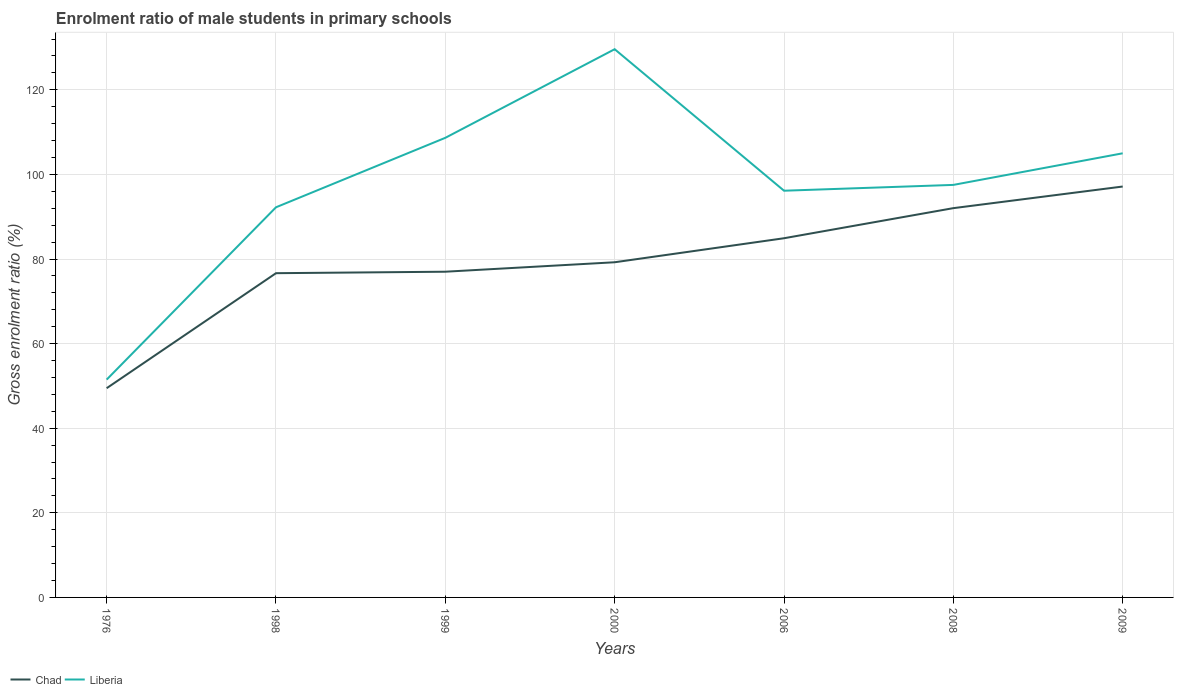How many different coloured lines are there?
Provide a short and direct response. 2. Is the number of lines equal to the number of legend labels?
Your response must be concise. Yes. Across all years, what is the maximum enrolment ratio of male students in primary schools in Chad?
Make the answer very short. 49.46. In which year was the enrolment ratio of male students in primary schools in Liberia maximum?
Give a very brief answer. 1976. What is the total enrolment ratio of male students in primary schools in Chad in the graph?
Your response must be concise. -29.77. What is the difference between the highest and the second highest enrolment ratio of male students in primary schools in Chad?
Your answer should be compact. 47.68. What is the difference between the highest and the lowest enrolment ratio of male students in primary schools in Liberia?
Make the answer very short. 4. How many lines are there?
Give a very brief answer. 2. How many years are there in the graph?
Keep it short and to the point. 7. Are the values on the major ticks of Y-axis written in scientific E-notation?
Your response must be concise. No. Does the graph contain any zero values?
Your answer should be compact. No. Does the graph contain grids?
Your answer should be compact. Yes. How are the legend labels stacked?
Provide a short and direct response. Horizontal. What is the title of the graph?
Provide a succinct answer. Enrolment ratio of male students in primary schools. What is the label or title of the X-axis?
Your response must be concise. Years. What is the label or title of the Y-axis?
Your response must be concise. Gross enrolment ratio (%). What is the Gross enrolment ratio (%) of Chad in 1976?
Make the answer very short. 49.46. What is the Gross enrolment ratio (%) in Liberia in 1976?
Your answer should be very brief. 51.49. What is the Gross enrolment ratio (%) of Chad in 1998?
Offer a very short reply. 76.65. What is the Gross enrolment ratio (%) in Liberia in 1998?
Make the answer very short. 92.23. What is the Gross enrolment ratio (%) in Chad in 1999?
Provide a succinct answer. 77. What is the Gross enrolment ratio (%) of Liberia in 1999?
Your answer should be compact. 108.65. What is the Gross enrolment ratio (%) in Chad in 2000?
Offer a very short reply. 79.23. What is the Gross enrolment ratio (%) in Liberia in 2000?
Give a very brief answer. 129.6. What is the Gross enrolment ratio (%) of Chad in 2006?
Ensure brevity in your answer.  84.91. What is the Gross enrolment ratio (%) of Liberia in 2006?
Your answer should be very brief. 96.14. What is the Gross enrolment ratio (%) in Chad in 2008?
Offer a very short reply. 92.02. What is the Gross enrolment ratio (%) of Liberia in 2008?
Keep it short and to the point. 97.52. What is the Gross enrolment ratio (%) of Chad in 2009?
Offer a very short reply. 97.14. What is the Gross enrolment ratio (%) in Liberia in 2009?
Provide a short and direct response. 104.99. Across all years, what is the maximum Gross enrolment ratio (%) in Chad?
Give a very brief answer. 97.14. Across all years, what is the maximum Gross enrolment ratio (%) of Liberia?
Your answer should be compact. 129.6. Across all years, what is the minimum Gross enrolment ratio (%) of Chad?
Make the answer very short. 49.46. Across all years, what is the minimum Gross enrolment ratio (%) in Liberia?
Give a very brief answer. 51.49. What is the total Gross enrolment ratio (%) in Chad in the graph?
Keep it short and to the point. 556.4. What is the total Gross enrolment ratio (%) in Liberia in the graph?
Offer a terse response. 680.62. What is the difference between the Gross enrolment ratio (%) of Chad in 1976 and that in 1998?
Keep it short and to the point. -27.19. What is the difference between the Gross enrolment ratio (%) of Liberia in 1976 and that in 1998?
Your answer should be very brief. -40.74. What is the difference between the Gross enrolment ratio (%) of Chad in 1976 and that in 1999?
Your answer should be very brief. -27.54. What is the difference between the Gross enrolment ratio (%) of Liberia in 1976 and that in 1999?
Your response must be concise. -57.16. What is the difference between the Gross enrolment ratio (%) in Chad in 1976 and that in 2000?
Your answer should be very brief. -29.77. What is the difference between the Gross enrolment ratio (%) in Liberia in 1976 and that in 2000?
Your answer should be very brief. -78.11. What is the difference between the Gross enrolment ratio (%) of Chad in 1976 and that in 2006?
Keep it short and to the point. -35.45. What is the difference between the Gross enrolment ratio (%) of Liberia in 1976 and that in 2006?
Provide a short and direct response. -44.65. What is the difference between the Gross enrolment ratio (%) of Chad in 1976 and that in 2008?
Ensure brevity in your answer.  -42.56. What is the difference between the Gross enrolment ratio (%) of Liberia in 1976 and that in 2008?
Your answer should be very brief. -46.03. What is the difference between the Gross enrolment ratio (%) of Chad in 1976 and that in 2009?
Make the answer very short. -47.68. What is the difference between the Gross enrolment ratio (%) in Liberia in 1976 and that in 2009?
Give a very brief answer. -53.5. What is the difference between the Gross enrolment ratio (%) in Chad in 1998 and that in 1999?
Your answer should be very brief. -0.35. What is the difference between the Gross enrolment ratio (%) in Liberia in 1998 and that in 1999?
Your answer should be very brief. -16.42. What is the difference between the Gross enrolment ratio (%) of Chad in 1998 and that in 2000?
Give a very brief answer. -2.58. What is the difference between the Gross enrolment ratio (%) of Liberia in 1998 and that in 2000?
Your response must be concise. -37.37. What is the difference between the Gross enrolment ratio (%) of Chad in 1998 and that in 2006?
Keep it short and to the point. -8.26. What is the difference between the Gross enrolment ratio (%) of Liberia in 1998 and that in 2006?
Keep it short and to the point. -3.92. What is the difference between the Gross enrolment ratio (%) in Chad in 1998 and that in 2008?
Your answer should be compact. -15.38. What is the difference between the Gross enrolment ratio (%) in Liberia in 1998 and that in 2008?
Ensure brevity in your answer.  -5.29. What is the difference between the Gross enrolment ratio (%) in Chad in 1998 and that in 2009?
Your answer should be very brief. -20.49. What is the difference between the Gross enrolment ratio (%) in Liberia in 1998 and that in 2009?
Give a very brief answer. -12.76. What is the difference between the Gross enrolment ratio (%) in Chad in 1999 and that in 2000?
Provide a short and direct response. -2.23. What is the difference between the Gross enrolment ratio (%) of Liberia in 1999 and that in 2000?
Your answer should be very brief. -20.95. What is the difference between the Gross enrolment ratio (%) of Chad in 1999 and that in 2006?
Offer a very short reply. -7.91. What is the difference between the Gross enrolment ratio (%) of Liberia in 1999 and that in 2006?
Your answer should be compact. 12.51. What is the difference between the Gross enrolment ratio (%) in Chad in 1999 and that in 2008?
Provide a succinct answer. -15.03. What is the difference between the Gross enrolment ratio (%) in Liberia in 1999 and that in 2008?
Make the answer very short. 11.13. What is the difference between the Gross enrolment ratio (%) of Chad in 1999 and that in 2009?
Your answer should be compact. -20.14. What is the difference between the Gross enrolment ratio (%) in Liberia in 1999 and that in 2009?
Offer a terse response. 3.66. What is the difference between the Gross enrolment ratio (%) of Chad in 2000 and that in 2006?
Make the answer very short. -5.68. What is the difference between the Gross enrolment ratio (%) in Liberia in 2000 and that in 2006?
Ensure brevity in your answer.  33.45. What is the difference between the Gross enrolment ratio (%) of Chad in 2000 and that in 2008?
Your answer should be compact. -12.79. What is the difference between the Gross enrolment ratio (%) in Liberia in 2000 and that in 2008?
Offer a terse response. 32.08. What is the difference between the Gross enrolment ratio (%) in Chad in 2000 and that in 2009?
Provide a succinct answer. -17.9. What is the difference between the Gross enrolment ratio (%) in Liberia in 2000 and that in 2009?
Provide a short and direct response. 24.61. What is the difference between the Gross enrolment ratio (%) of Chad in 2006 and that in 2008?
Offer a very short reply. -7.11. What is the difference between the Gross enrolment ratio (%) of Liberia in 2006 and that in 2008?
Offer a very short reply. -1.37. What is the difference between the Gross enrolment ratio (%) in Chad in 2006 and that in 2009?
Provide a short and direct response. -12.23. What is the difference between the Gross enrolment ratio (%) of Liberia in 2006 and that in 2009?
Offer a terse response. -8.84. What is the difference between the Gross enrolment ratio (%) in Chad in 2008 and that in 2009?
Your answer should be very brief. -5.11. What is the difference between the Gross enrolment ratio (%) in Liberia in 2008 and that in 2009?
Ensure brevity in your answer.  -7.47. What is the difference between the Gross enrolment ratio (%) in Chad in 1976 and the Gross enrolment ratio (%) in Liberia in 1998?
Offer a terse response. -42.77. What is the difference between the Gross enrolment ratio (%) of Chad in 1976 and the Gross enrolment ratio (%) of Liberia in 1999?
Ensure brevity in your answer.  -59.19. What is the difference between the Gross enrolment ratio (%) of Chad in 1976 and the Gross enrolment ratio (%) of Liberia in 2000?
Offer a terse response. -80.14. What is the difference between the Gross enrolment ratio (%) of Chad in 1976 and the Gross enrolment ratio (%) of Liberia in 2006?
Your response must be concise. -46.68. What is the difference between the Gross enrolment ratio (%) in Chad in 1976 and the Gross enrolment ratio (%) in Liberia in 2008?
Your answer should be compact. -48.06. What is the difference between the Gross enrolment ratio (%) of Chad in 1976 and the Gross enrolment ratio (%) of Liberia in 2009?
Keep it short and to the point. -55.53. What is the difference between the Gross enrolment ratio (%) in Chad in 1998 and the Gross enrolment ratio (%) in Liberia in 1999?
Give a very brief answer. -32. What is the difference between the Gross enrolment ratio (%) of Chad in 1998 and the Gross enrolment ratio (%) of Liberia in 2000?
Keep it short and to the point. -52.95. What is the difference between the Gross enrolment ratio (%) in Chad in 1998 and the Gross enrolment ratio (%) in Liberia in 2006?
Offer a terse response. -19.5. What is the difference between the Gross enrolment ratio (%) in Chad in 1998 and the Gross enrolment ratio (%) in Liberia in 2008?
Provide a short and direct response. -20.87. What is the difference between the Gross enrolment ratio (%) in Chad in 1998 and the Gross enrolment ratio (%) in Liberia in 2009?
Give a very brief answer. -28.34. What is the difference between the Gross enrolment ratio (%) in Chad in 1999 and the Gross enrolment ratio (%) in Liberia in 2000?
Offer a very short reply. -52.6. What is the difference between the Gross enrolment ratio (%) of Chad in 1999 and the Gross enrolment ratio (%) of Liberia in 2006?
Offer a very short reply. -19.15. What is the difference between the Gross enrolment ratio (%) in Chad in 1999 and the Gross enrolment ratio (%) in Liberia in 2008?
Give a very brief answer. -20.52. What is the difference between the Gross enrolment ratio (%) in Chad in 1999 and the Gross enrolment ratio (%) in Liberia in 2009?
Offer a very short reply. -27.99. What is the difference between the Gross enrolment ratio (%) of Chad in 2000 and the Gross enrolment ratio (%) of Liberia in 2006?
Ensure brevity in your answer.  -16.91. What is the difference between the Gross enrolment ratio (%) in Chad in 2000 and the Gross enrolment ratio (%) in Liberia in 2008?
Provide a succinct answer. -18.29. What is the difference between the Gross enrolment ratio (%) in Chad in 2000 and the Gross enrolment ratio (%) in Liberia in 2009?
Offer a terse response. -25.76. What is the difference between the Gross enrolment ratio (%) of Chad in 2006 and the Gross enrolment ratio (%) of Liberia in 2008?
Provide a short and direct response. -12.61. What is the difference between the Gross enrolment ratio (%) in Chad in 2006 and the Gross enrolment ratio (%) in Liberia in 2009?
Your answer should be compact. -20.08. What is the difference between the Gross enrolment ratio (%) in Chad in 2008 and the Gross enrolment ratio (%) in Liberia in 2009?
Offer a very short reply. -12.97. What is the average Gross enrolment ratio (%) in Chad per year?
Keep it short and to the point. 79.49. What is the average Gross enrolment ratio (%) of Liberia per year?
Give a very brief answer. 97.23. In the year 1976, what is the difference between the Gross enrolment ratio (%) of Chad and Gross enrolment ratio (%) of Liberia?
Your response must be concise. -2.03. In the year 1998, what is the difference between the Gross enrolment ratio (%) of Chad and Gross enrolment ratio (%) of Liberia?
Your answer should be very brief. -15.58. In the year 1999, what is the difference between the Gross enrolment ratio (%) of Chad and Gross enrolment ratio (%) of Liberia?
Offer a terse response. -31.65. In the year 2000, what is the difference between the Gross enrolment ratio (%) of Chad and Gross enrolment ratio (%) of Liberia?
Offer a very short reply. -50.37. In the year 2006, what is the difference between the Gross enrolment ratio (%) in Chad and Gross enrolment ratio (%) in Liberia?
Provide a short and direct response. -11.24. In the year 2008, what is the difference between the Gross enrolment ratio (%) in Chad and Gross enrolment ratio (%) in Liberia?
Offer a very short reply. -5.49. In the year 2009, what is the difference between the Gross enrolment ratio (%) of Chad and Gross enrolment ratio (%) of Liberia?
Your response must be concise. -7.85. What is the ratio of the Gross enrolment ratio (%) of Chad in 1976 to that in 1998?
Your answer should be compact. 0.65. What is the ratio of the Gross enrolment ratio (%) in Liberia in 1976 to that in 1998?
Offer a terse response. 0.56. What is the ratio of the Gross enrolment ratio (%) of Chad in 1976 to that in 1999?
Offer a very short reply. 0.64. What is the ratio of the Gross enrolment ratio (%) in Liberia in 1976 to that in 1999?
Provide a succinct answer. 0.47. What is the ratio of the Gross enrolment ratio (%) in Chad in 1976 to that in 2000?
Give a very brief answer. 0.62. What is the ratio of the Gross enrolment ratio (%) in Liberia in 1976 to that in 2000?
Give a very brief answer. 0.4. What is the ratio of the Gross enrolment ratio (%) of Chad in 1976 to that in 2006?
Make the answer very short. 0.58. What is the ratio of the Gross enrolment ratio (%) in Liberia in 1976 to that in 2006?
Keep it short and to the point. 0.54. What is the ratio of the Gross enrolment ratio (%) in Chad in 1976 to that in 2008?
Offer a terse response. 0.54. What is the ratio of the Gross enrolment ratio (%) in Liberia in 1976 to that in 2008?
Your answer should be very brief. 0.53. What is the ratio of the Gross enrolment ratio (%) in Chad in 1976 to that in 2009?
Ensure brevity in your answer.  0.51. What is the ratio of the Gross enrolment ratio (%) in Liberia in 1976 to that in 2009?
Your answer should be compact. 0.49. What is the ratio of the Gross enrolment ratio (%) in Chad in 1998 to that in 1999?
Give a very brief answer. 1. What is the ratio of the Gross enrolment ratio (%) of Liberia in 1998 to that in 1999?
Ensure brevity in your answer.  0.85. What is the ratio of the Gross enrolment ratio (%) in Chad in 1998 to that in 2000?
Offer a very short reply. 0.97. What is the ratio of the Gross enrolment ratio (%) of Liberia in 1998 to that in 2000?
Offer a very short reply. 0.71. What is the ratio of the Gross enrolment ratio (%) in Chad in 1998 to that in 2006?
Offer a terse response. 0.9. What is the ratio of the Gross enrolment ratio (%) of Liberia in 1998 to that in 2006?
Make the answer very short. 0.96. What is the ratio of the Gross enrolment ratio (%) in Chad in 1998 to that in 2008?
Keep it short and to the point. 0.83. What is the ratio of the Gross enrolment ratio (%) in Liberia in 1998 to that in 2008?
Offer a very short reply. 0.95. What is the ratio of the Gross enrolment ratio (%) in Chad in 1998 to that in 2009?
Your answer should be compact. 0.79. What is the ratio of the Gross enrolment ratio (%) in Liberia in 1998 to that in 2009?
Offer a terse response. 0.88. What is the ratio of the Gross enrolment ratio (%) of Chad in 1999 to that in 2000?
Make the answer very short. 0.97. What is the ratio of the Gross enrolment ratio (%) of Liberia in 1999 to that in 2000?
Keep it short and to the point. 0.84. What is the ratio of the Gross enrolment ratio (%) of Chad in 1999 to that in 2006?
Make the answer very short. 0.91. What is the ratio of the Gross enrolment ratio (%) in Liberia in 1999 to that in 2006?
Provide a short and direct response. 1.13. What is the ratio of the Gross enrolment ratio (%) of Chad in 1999 to that in 2008?
Ensure brevity in your answer.  0.84. What is the ratio of the Gross enrolment ratio (%) of Liberia in 1999 to that in 2008?
Provide a succinct answer. 1.11. What is the ratio of the Gross enrolment ratio (%) of Chad in 1999 to that in 2009?
Your response must be concise. 0.79. What is the ratio of the Gross enrolment ratio (%) in Liberia in 1999 to that in 2009?
Offer a terse response. 1.03. What is the ratio of the Gross enrolment ratio (%) of Chad in 2000 to that in 2006?
Your answer should be very brief. 0.93. What is the ratio of the Gross enrolment ratio (%) of Liberia in 2000 to that in 2006?
Your answer should be compact. 1.35. What is the ratio of the Gross enrolment ratio (%) of Chad in 2000 to that in 2008?
Keep it short and to the point. 0.86. What is the ratio of the Gross enrolment ratio (%) of Liberia in 2000 to that in 2008?
Your answer should be very brief. 1.33. What is the ratio of the Gross enrolment ratio (%) in Chad in 2000 to that in 2009?
Give a very brief answer. 0.82. What is the ratio of the Gross enrolment ratio (%) in Liberia in 2000 to that in 2009?
Your answer should be very brief. 1.23. What is the ratio of the Gross enrolment ratio (%) of Chad in 2006 to that in 2008?
Your response must be concise. 0.92. What is the ratio of the Gross enrolment ratio (%) in Liberia in 2006 to that in 2008?
Provide a short and direct response. 0.99. What is the ratio of the Gross enrolment ratio (%) of Chad in 2006 to that in 2009?
Your answer should be compact. 0.87. What is the ratio of the Gross enrolment ratio (%) in Liberia in 2006 to that in 2009?
Offer a terse response. 0.92. What is the ratio of the Gross enrolment ratio (%) of Liberia in 2008 to that in 2009?
Provide a succinct answer. 0.93. What is the difference between the highest and the second highest Gross enrolment ratio (%) in Chad?
Your answer should be compact. 5.11. What is the difference between the highest and the second highest Gross enrolment ratio (%) in Liberia?
Your answer should be compact. 20.95. What is the difference between the highest and the lowest Gross enrolment ratio (%) in Chad?
Give a very brief answer. 47.68. What is the difference between the highest and the lowest Gross enrolment ratio (%) in Liberia?
Offer a very short reply. 78.11. 